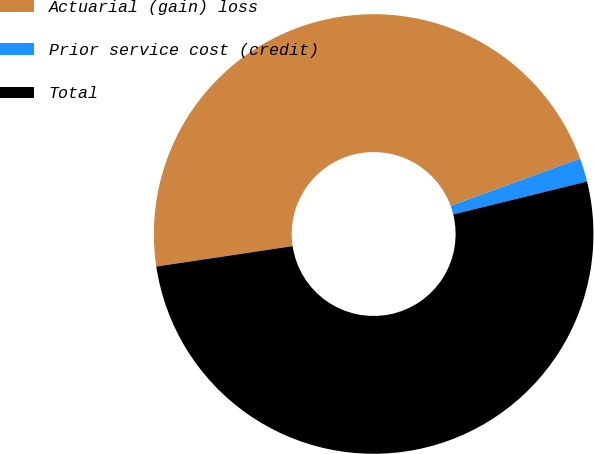Convert chart to OTSL. <chart><loc_0><loc_0><loc_500><loc_500><pie_chart><fcel>Actuarial (gain) loss<fcel>Prior service cost (credit)<fcel>Total<nl><fcel>46.79%<fcel>1.73%<fcel>51.47%<nl></chart> 